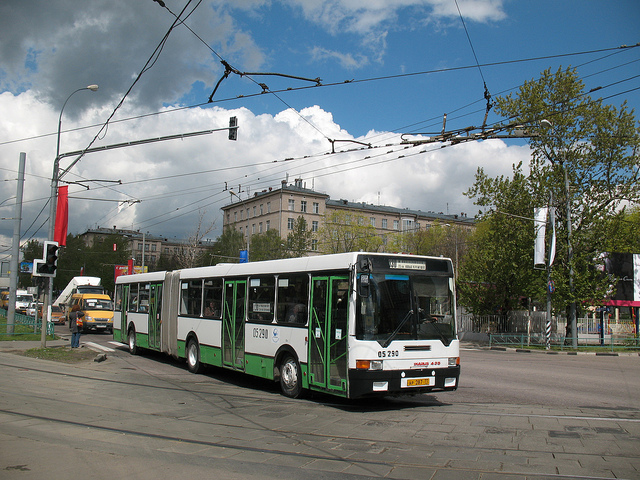Identify the text displayed in this image. 290 05 05 290 